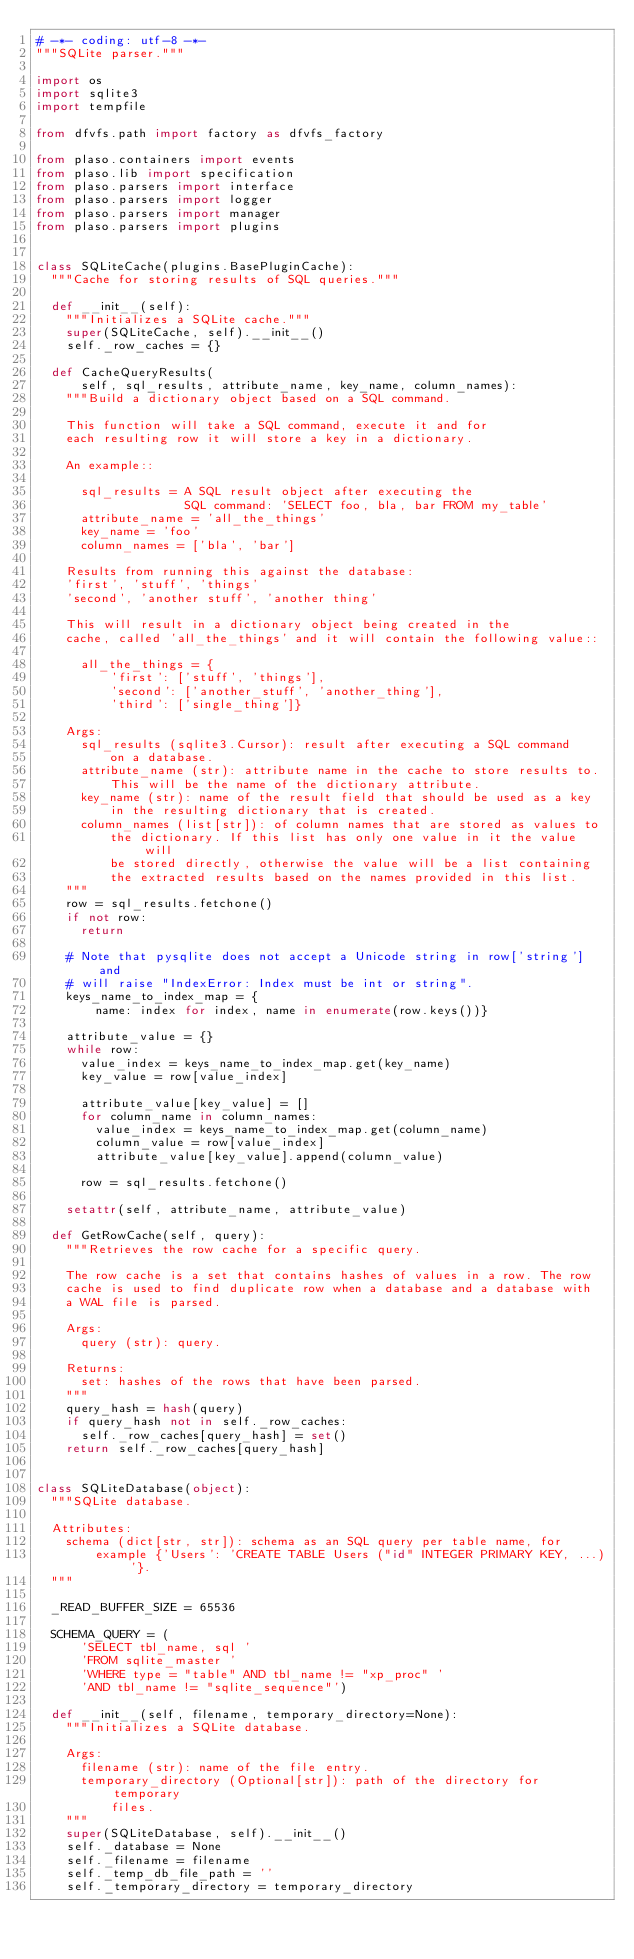<code> <loc_0><loc_0><loc_500><loc_500><_Python_># -*- coding: utf-8 -*-
"""SQLite parser."""

import os
import sqlite3
import tempfile

from dfvfs.path import factory as dfvfs_factory

from plaso.containers import events
from plaso.lib import specification
from plaso.parsers import interface
from plaso.parsers import logger
from plaso.parsers import manager
from plaso.parsers import plugins


class SQLiteCache(plugins.BasePluginCache):
  """Cache for storing results of SQL queries."""

  def __init__(self):
    """Initializes a SQLite cache."""
    super(SQLiteCache, self).__init__()
    self._row_caches = {}

  def CacheQueryResults(
      self, sql_results, attribute_name, key_name, column_names):
    """Build a dictionary object based on a SQL command.

    This function will take a SQL command, execute it and for
    each resulting row it will store a key in a dictionary.

    An example::

      sql_results = A SQL result object after executing the
                    SQL command: 'SELECT foo, bla, bar FROM my_table'
      attribute_name = 'all_the_things'
      key_name = 'foo'
      column_names = ['bla', 'bar']

    Results from running this against the database:
    'first', 'stuff', 'things'
    'second', 'another stuff', 'another thing'

    This will result in a dictionary object being created in the
    cache, called 'all_the_things' and it will contain the following value::

      all_the_things = {
          'first': ['stuff', 'things'],
          'second': ['another_stuff', 'another_thing'],
          'third': ['single_thing']}

    Args:
      sql_results (sqlite3.Cursor): result after executing a SQL command
          on a database.
      attribute_name (str): attribute name in the cache to store results to.
          This will be the name of the dictionary attribute.
      key_name (str): name of the result field that should be used as a key
          in the resulting dictionary that is created.
      column_names (list[str]): of column names that are stored as values to
          the dictionary. If this list has only one value in it the value will
          be stored directly, otherwise the value will be a list containing
          the extracted results based on the names provided in this list.
    """
    row = sql_results.fetchone()
    if not row:
      return

    # Note that pysqlite does not accept a Unicode string in row['string'] and
    # will raise "IndexError: Index must be int or string".
    keys_name_to_index_map = {
        name: index for index, name in enumerate(row.keys())}

    attribute_value = {}
    while row:
      value_index = keys_name_to_index_map.get(key_name)
      key_value = row[value_index]

      attribute_value[key_value] = []
      for column_name in column_names:
        value_index = keys_name_to_index_map.get(column_name)
        column_value = row[value_index]
        attribute_value[key_value].append(column_value)

      row = sql_results.fetchone()

    setattr(self, attribute_name, attribute_value)

  def GetRowCache(self, query):
    """Retrieves the row cache for a specific query.

    The row cache is a set that contains hashes of values in a row. The row
    cache is used to find duplicate row when a database and a database with
    a WAL file is parsed.

    Args:
      query (str): query.

    Returns:
      set: hashes of the rows that have been parsed.
    """
    query_hash = hash(query)
    if query_hash not in self._row_caches:
      self._row_caches[query_hash] = set()
    return self._row_caches[query_hash]


class SQLiteDatabase(object):
  """SQLite database.

  Attributes:
    schema (dict[str, str]): schema as an SQL query per table name, for
        example {'Users': 'CREATE TABLE Users ("id" INTEGER PRIMARY KEY, ...)'}.
  """

  _READ_BUFFER_SIZE = 65536

  SCHEMA_QUERY = (
      'SELECT tbl_name, sql '
      'FROM sqlite_master '
      'WHERE type = "table" AND tbl_name != "xp_proc" '
      'AND tbl_name != "sqlite_sequence"')

  def __init__(self, filename, temporary_directory=None):
    """Initializes a SQLite database.

    Args:
      filename (str): name of the file entry.
      temporary_directory (Optional[str]): path of the directory for temporary
          files.
    """
    super(SQLiteDatabase, self).__init__()
    self._database = None
    self._filename = filename
    self._temp_db_file_path = ''
    self._temporary_directory = temporary_directory</code> 